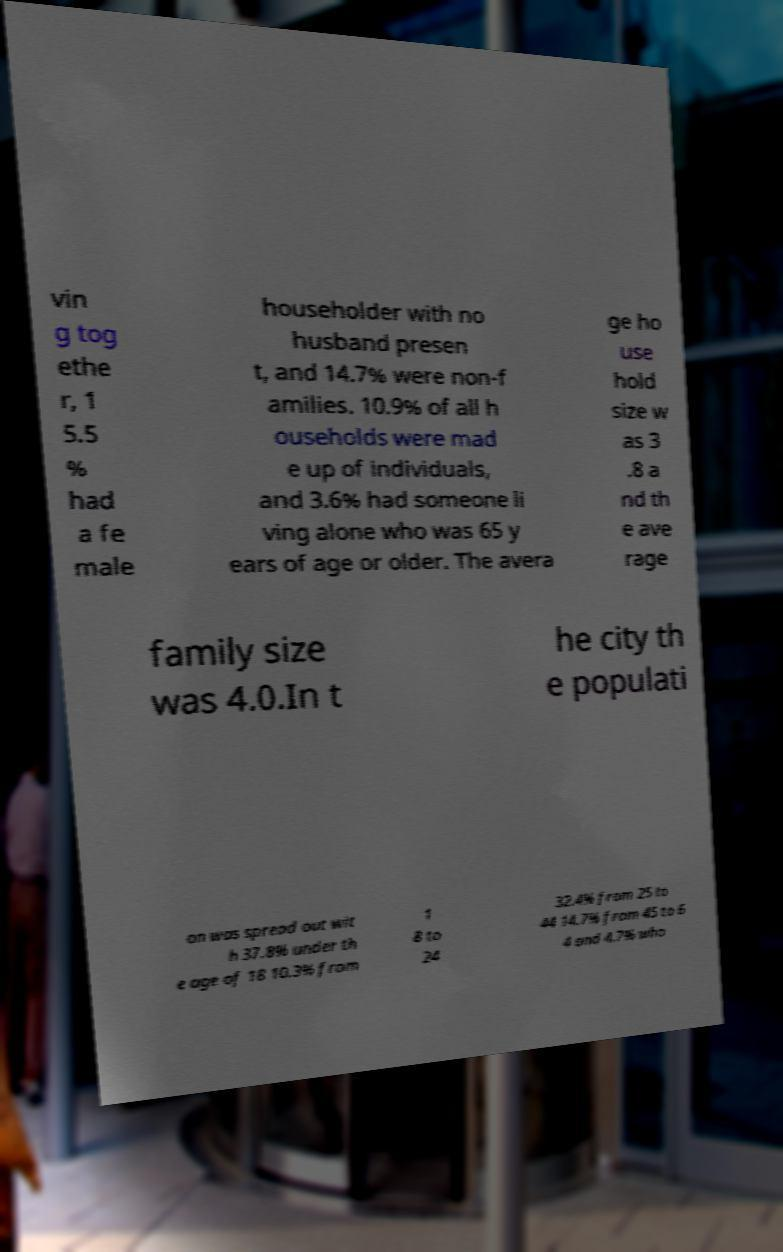For documentation purposes, I need the text within this image transcribed. Could you provide that? vin g tog ethe r, 1 5.5 % had a fe male householder with no husband presen t, and 14.7% were non-f amilies. 10.9% of all h ouseholds were mad e up of individuals, and 3.6% had someone li ving alone who was 65 y ears of age or older. The avera ge ho use hold size w as 3 .8 a nd th e ave rage family size was 4.0.In t he city th e populati on was spread out wit h 37.8% under th e age of 18 10.3% from 1 8 to 24 32.4% from 25 to 44 14.7% from 45 to 6 4 and 4.7% who 